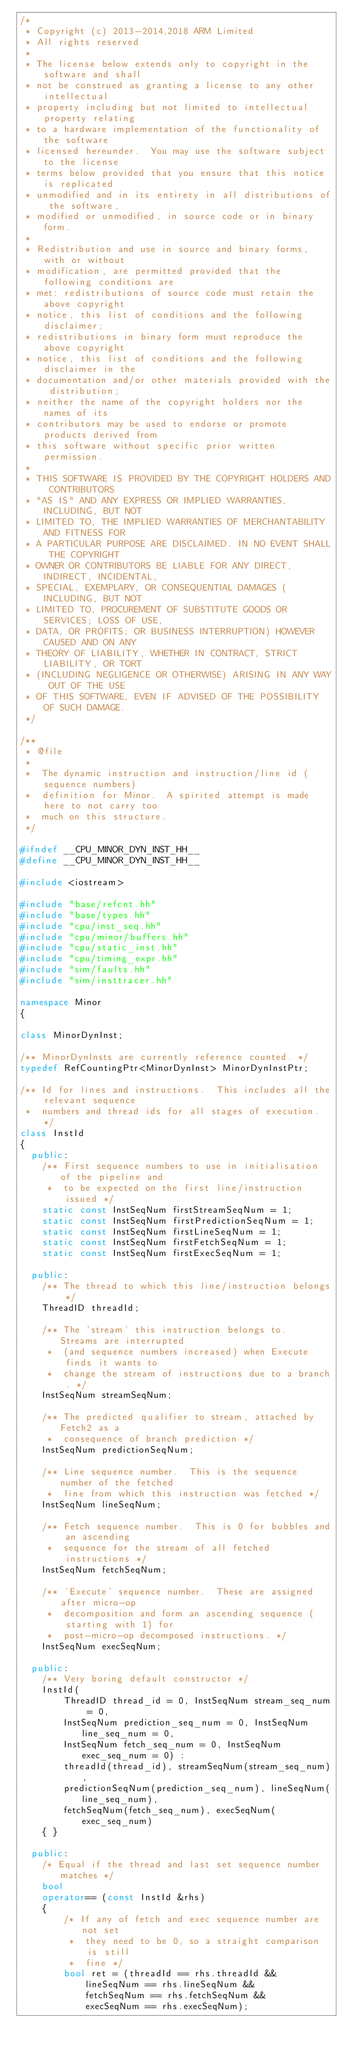Convert code to text. <code><loc_0><loc_0><loc_500><loc_500><_C++_>/*
 * Copyright (c) 2013-2014,2018 ARM Limited
 * All rights reserved
 *
 * The license below extends only to copyright in the software and shall
 * not be construed as granting a license to any other intellectual
 * property including but not limited to intellectual property relating
 * to a hardware implementation of the functionality of the software
 * licensed hereunder.  You may use the software subject to the license
 * terms below provided that you ensure that this notice is replicated
 * unmodified and in its entirety in all distributions of the software,
 * modified or unmodified, in source code or in binary form.
 *
 * Redistribution and use in source and binary forms, with or without
 * modification, are permitted provided that the following conditions are
 * met: redistributions of source code must retain the above copyright
 * notice, this list of conditions and the following disclaimer;
 * redistributions in binary form must reproduce the above copyright
 * notice, this list of conditions and the following disclaimer in the
 * documentation and/or other materials provided with the distribution;
 * neither the name of the copyright holders nor the names of its
 * contributors may be used to endorse or promote products derived from
 * this software without specific prior written permission.
 *
 * THIS SOFTWARE IS PROVIDED BY THE COPYRIGHT HOLDERS AND CONTRIBUTORS
 * "AS IS" AND ANY EXPRESS OR IMPLIED WARRANTIES, INCLUDING, BUT NOT
 * LIMITED TO, THE IMPLIED WARRANTIES OF MERCHANTABILITY AND FITNESS FOR
 * A PARTICULAR PURPOSE ARE DISCLAIMED. IN NO EVENT SHALL THE COPYRIGHT
 * OWNER OR CONTRIBUTORS BE LIABLE FOR ANY DIRECT, INDIRECT, INCIDENTAL,
 * SPECIAL, EXEMPLARY, OR CONSEQUENTIAL DAMAGES (INCLUDING, BUT NOT
 * LIMITED TO, PROCUREMENT OF SUBSTITUTE GOODS OR SERVICES; LOSS OF USE,
 * DATA, OR PROFITS; OR BUSINESS INTERRUPTION) HOWEVER CAUSED AND ON ANY
 * THEORY OF LIABILITY, WHETHER IN CONTRACT, STRICT LIABILITY, OR TORT
 * (INCLUDING NEGLIGENCE OR OTHERWISE) ARISING IN ANY WAY OUT OF THE USE
 * OF THIS SOFTWARE, EVEN IF ADVISED OF THE POSSIBILITY OF SUCH DAMAGE.
 */

/**
 * @file
 *
 *  The dynamic instruction and instruction/line id (sequence numbers)
 *  definition for Minor.  A spirited attempt is made here to not carry too
 *  much on this structure.
 */

#ifndef __CPU_MINOR_DYN_INST_HH__
#define __CPU_MINOR_DYN_INST_HH__

#include <iostream>

#include "base/refcnt.hh"
#include "base/types.hh"
#include "cpu/inst_seq.hh"
#include "cpu/minor/buffers.hh"
#include "cpu/static_inst.hh"
#include "cpu/timing_expr.hh"
#include "sim/faults.hh"
#include "sim/insttracer.hh"

namespace Minor
{

class MinorDynInst;

/** MinorDynInsts are currently reference counted. */
typedef RefCountingPtr<MinorDynInst> MinorDynInstPtr;

/** Id for lines and instructions.  This includes all the relevant sequence
 *  numbers and thread ids for all stages of execution. */
class InstId
{
  public:
    /** First sequence numbers to use in initialisation of the pipeline and
     *  to be expected on the first line/instruction issued */
    static const InstSeqNum firstStreamSeqNum = 1;
    static const InstSeqNum firstPredictionSeqNum = 1;
    static const InstSeqNum firstLineSeqNum = 1;
    static const InstSeqNum firstFetchSeqNum = 1;
    static const InstSeqNum firstExecSeqNum = 1;

  public:
    /** The thread to which this line/instruction belongs */
    ThreadID threadId;

    /** The 'stream' this instruction belongs to.  Streams are interrupted
     *  (and sequence numbers increased) when Execute finds it wants to
     *  change the stream of instructions due to a branch. */
    InstSeqNum streamSeqNum;

    /** The predicted qualifier to stream, attached by Fetch2 as a
     *  consequence of branch prediction */
    InstSeqNum predictionSeqNum;

    /** Line sequence number.  This is the sequence number of the fetched
     *  line from which this instruction was fetched */
    InstSeqNum lineSeqNum;

    /** Fetch sequence number.  This is 0 for bubbles and an ascending
     *  sequence for the stream of all fetched instructions */
    InstSeqNum fetchSeqNum;

    /** 'Execute' sequence number.  These are assigned after micro-op
     *  decomposition and form an ascending sequence (starting with 1) for
     *  post-micro-op decomposed instructions. */
    InstSeqNum execSeqNum;

  public:
    /** Very boring default constructor */
    InstId(
        ThreadID thread_id = 0, InstSeqNum stream_seq_num = 0,
        InstSeqNum prediction_seq_num = 0, InstSeqNum line_seq_num = 0,
        InstSeqNum fetch_seq_num = 0, InstSeqNum exec_seq_num = 0) :
        threadId(thread_id), streamSeqNum(stream_seq_num),
        predictionSeqNum(prediction_seq_num), lineSeqNum(line_seq_num),
        fetchSeqNum(fetch_seq_num), execSeqNum(exec_seq_num)
    { }

  public:
    /* Equal if the thread and last set sequence number matches */
    bool
    operator== (const InstId &rhs)
    {
        /* If any of fetch and exec sequence number are not set
         *  they need to be 0, so a straight comparison is still
         *  fine */
        bool ret = (threadId == rhs.threadId &&
            lineSeqNum == rhs.lineSeqNum &&
            fetchSeqNum == rhs.fetchSeqNum &&
            execSeqNum == rhs.execSeqNum);
</code> 